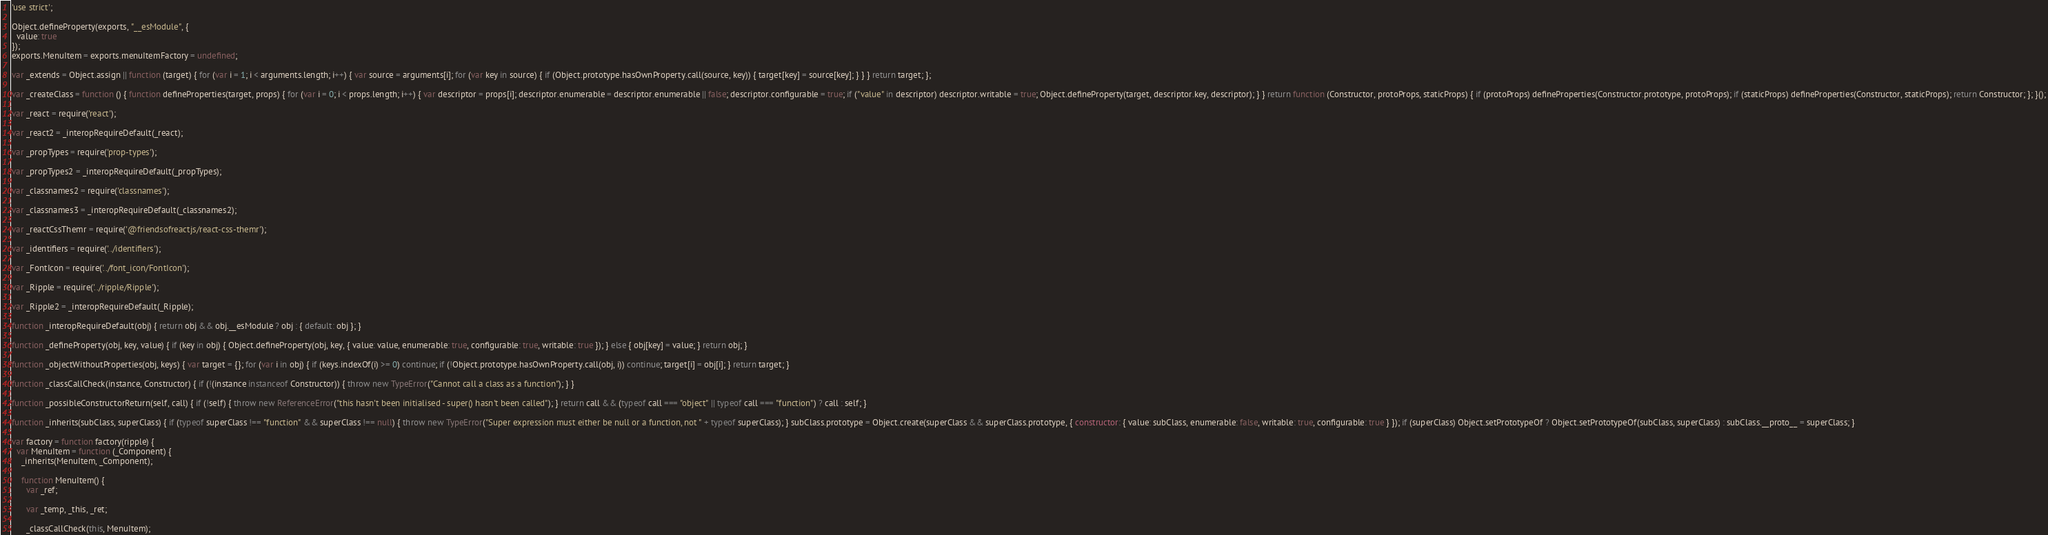<code> <loc_0><loc_0><loc_500><loc_500><_JavaScript_>'use strict';

Object.defineProperty(exports, "__esModule", {
  value: true
});
exports.MenuItem = exports.menuItemFactory = undefined;

var _extends = Object.assign || function (target) { for (var i = 1; i < arguments.length; i++) { var source = arguments[i]; for (var key in source) { if (Object.prototype.hasOwnProperty.call(source, key)) { target[key] = source[key]; } } } return target; };

var _createClass = function () { function defineProperties(target, props) { for (var i = 0; i < props.length; i++) { var descriptor = props[i]; descriptor.enumerable = descriptor.enumerable || false; descriptor.configurable = true; if ("value" in descriptor) descriptor.writable = true; Object.defineProperty(target, descriptor.key, descriptor); } } return function (Constructor, protoProps, staticProps) { if (protoProps) defineProperties(Constructor.prototype, protoProps); if (staticProps) defineProperties(Constructor, staticProps); return Constructor; }; }();

var _react = require('react');

var _react2 = _interopRequireDefault(_react);

var _propTypes = require('prop-types');

var _propTypes2 = _interopRequireDefault(_propTypes);

var _classnames2 = require('classnames');

var _classnames3 = _interopRequireDefault(_classnames2);

var _reactCssThemr = require('@friendsofreactjs/react-css-themr');

var _identifiers = require('../identifiers');

var _FontIcon = require('../font_icon/FontIcon');

var _Ripple = require('../ripple/Ripple');

var _Ripple2 = _interopRequireDefault(_Ripple);

function _interopRequireDefault(obj) { return obj && obj.__esModule ? obj : { default: obj }; }

function _defineProperty(obj, key, value) { if (key in obj) { Object.defineProperty(obj, key, { value: value, enumerable: true, configurable: true, writable: true }); } else { obj[key] = value; } return obj; }

function _objectWithoutProperties(obj, keys) { var target = {}; for (var i in obj) { if (keys.indexOf(i) >= 0) continue; if (!Object.prototype.hasOwnProperty.call(obj, i)) continue; target[i] = obj[i]; } return target; }

function _classCallCheck(instance, Constructor) { if (!(instance instanceof Constructor)) { throw new TypeError("Cannot call a class as a function"); } }

function _possibleConstructorReturn(self, call) { if (!self) { throw new ReferenceError("this hasn't been initialised - super() hasn't been called"); } return call && (typeof call === "object" || typeof call === "function") ? call : self; }

function _inherits(subClass, superClass) { if (typeof superClass !== "function" && superClass !== null) { throw new TypeError("Super expression must either be null or a function, not " + typeof superClass); } subClass.prototype = Object.create(superClass && superClass.prototype, { constructor: { value: subClass, enumerable: false, writable: true, configurable: true } }); if (superClass) Object.setPrototypeOf ? Object.setPrototypeOf(subClass, superClass) : subClass.__proto__ = superClass; }

var factory = function factory(ripple) {
  var MenuItem = function (_Component) {
    _inherits(MenuItem, _Component);

    function MenuItem() {
      var _ref;

      var _temp, _this, _ret;

      _classCallCheck(this, MenuItem);
</code> 